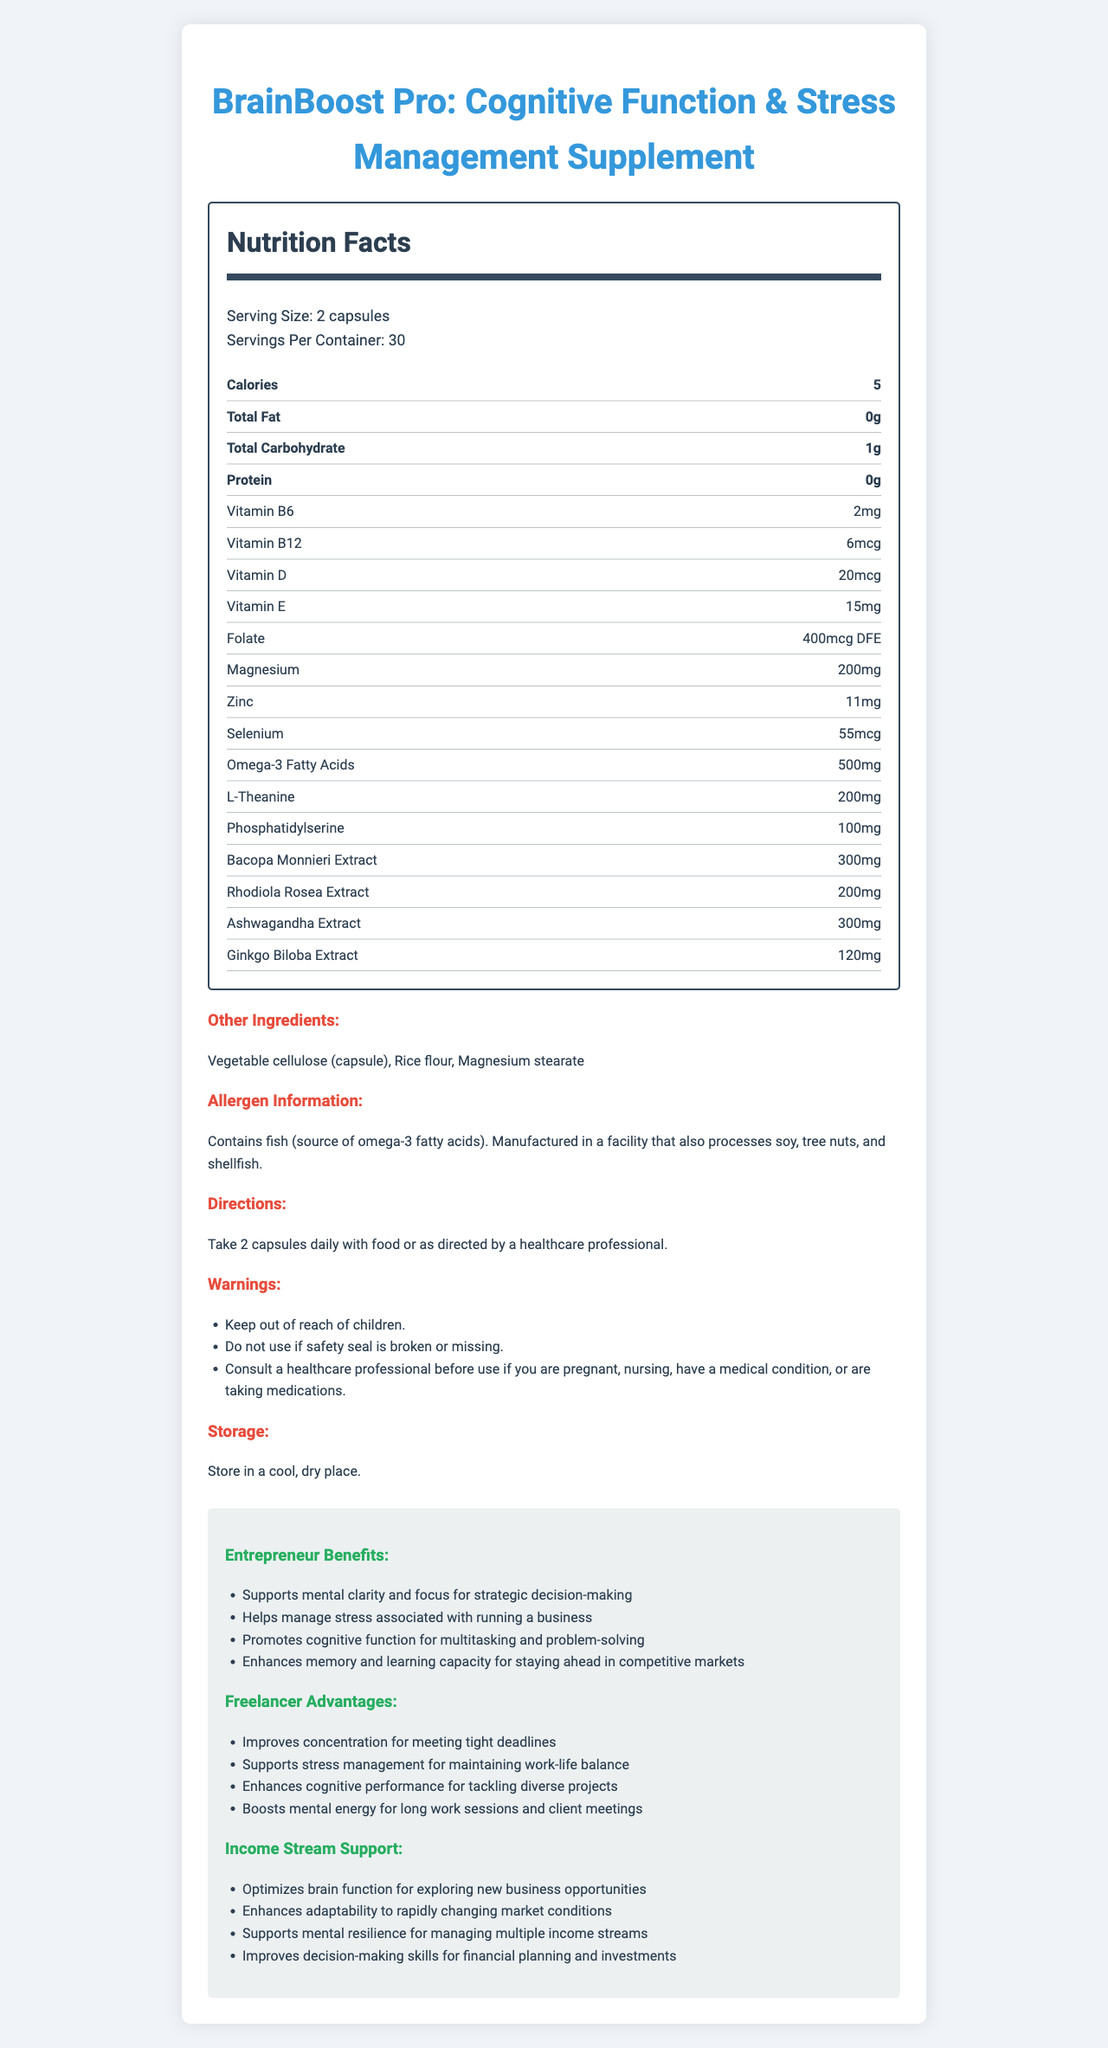what is the serving size for BrainBoost Pro? The serving size is clearly mentioned under the "Serving Size" section.
Answer: 2 capsules how many servings are there per container? The "Servings Per Container" section specifies that there are 30 servings per container.
Answer: 30 how many calories are in each serving? The Nutrition Facts label lists the number of calories per serving as 5.
Answer: 5 does BrainBoost Pro contain any protein? The "Protein" section shows "0g," indicating there is no protein in the supplement.
Answer: No which vitamin has the highest quantity per serving? Vitamin D has 20mcg per serving, which is the highest among the listed vitamins.
Answer: Vitamin D what is the amount of L-Theanine in each serving? The "L-Theanine" section specifies that there are 200mg of L-Theanine per serving.
Answer: 200mg Which of the following minerals is present in BrainBoost Pro?
A. Iron
B. Magnesium
C. Calcium
D. Copper The Nutrition Facts list Magnesium at 200mg per serving. There is no mention of Iron, Calcium, or Copper.
Answer: B which ingredient is an allergen? 
I. Fish
II. Soy
III. Peanuts
IV. Wheat The allergen information section specifies that the product contains fish, which is the source of omega-3 fatty acids.
Answer: I does this supplement support cognitive function? The title "BrainBoost Pro: Cognitive Function & Stress Management Supplement" suggests that it supports cognitive function. Additionally, the description under entrepreneur benefits and freelancer advantages includes cognitive function support.
Answer: Yes interpret the directions for using BrainBoost Pro The directions specify taking two capsules daily with food or following the instructions from a healthcare professional.
Answer: Take 2 capsules daily with food or as directed by a healthcare professional. what storage conditions are recommended for BrainBoost Pro? The storage information explicitly advises storing the supplement in cool and dry conditions.
Answer: Store in a cool, dry place. what additional benefits does BrainBoost Pro provide for entrepreneurs? The document lists specific benefits for entrepreneurs under the "Entrepreneur Benefits" section.
Answer: Supports mental clarity and focus, helps manage stress, promotes cognitive function, enhances memory and learning capacity does BrainBoost Pro contain any fish-derived ingredients? The allergen information mentions that it contains fish, which is the source of omega-3 fatty acids.
Answer: Yes summarize the main idea of BrainBoost Pro's document The document provides comprehensive information about the product, its nutritional content, usage instructions, allergens, and detailed benefits for different users.
Answer: BrainBoost Pro is a dietary supplement designed to support cognitive function and stress management with various vitamins, minerals, and natural extracts. It outlines serving size, nutrient content, directions, warnings, storage conditions, and specific benefits for entrepreneurs, freelancers, and those seeking to optimize brain function for income stream management. what is the percentage of daily value for vitamin B12 in BrainBoost Pro? The document does not provide any information about the percentage of daily value (%DV) for vitamin B12 or any other vitamin/mineral listed.
Answer: Cannot be determined 